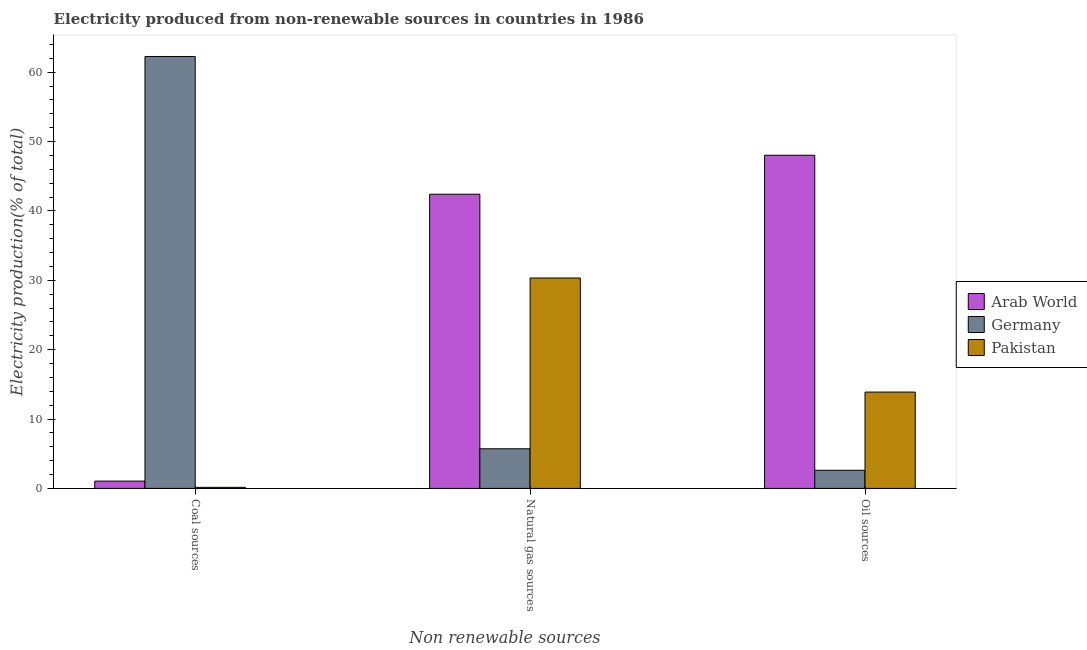How many different coloured bars are there?
Make the answer very short. 3. How many groups of bars are there?
Keep it short and to the point. 3. Are the number of bars on each tick of the X-axis equal?
Your response must be concise. Yes. What is the label of the 1st group of bars from the left?
Ensure brevity in your answer.  Coal sources. What is the percentage of electricity produced by coal in Arab World?
Keep it short and to the point. 1.06. Across all countries, what is the maximum percentage of electricity produced by coal?
Offer a terse response. 62.26. Across all countries, what is the minimum percentage of electricity produced by coal?
Offer a very short reply. 0.16. In which country was the percentage of electricity produced by natural gas maximum?
Ensure brevity in your answer.  Arab World. What is the total percentage of electricity produced by natural gas in the graph?
Give a very brief answer. 78.45. What is the difference between the percentage of electricity produced by oil sources in Germany and that in Arab World?
Offer a very short reply. -45.41. What is the difference between the percentage of electricity produced by oil sources in Pakistan and the percentage of electricity produced by natural gas in Arab World?
Your answer should be compact. -28.52. What is the average percentage of electricity produced by coal per country?
Your answer should be very brief. 21.16. What is the difference between the percentage of electricity produced by natural gas and percentage of electricity produced by oil sources in Arab World?
Your response must be concise. -5.62. In how many countries, is the percentage of electricity produced by coal greater than 46 %?
Make the answer very short. 1. What is the ratio of the percentage of electricity produced by natural gas in Pakistan to that in Arab World?
Provide a succinct answer. 0.72. What is the difference between the highest and the second highest percentage of electricity produced by natural gas?
Offer a terse response. 12.08. What is the difference between the highest and the lowest percentage of electricity produced by oil sources?
Keep it short and to the point. 45.41. What does the 1st bar from the left in Oil sources represents?
Ensure brevity in your answer.  Arab World. What does the 2nd bar from the right in Coal sources represents?
Ensure brevity in your answer.  Germany. Is it the case that in every country, the sum of the percentage of electricity produced by coal and percentage of electricity produced by natural gas is greater than the percentage of electricity produced by oil sources?
Give a very brief answer. No. How many bars are there?
Ensure brevity in your answer.  9. Are all the bars in the graph horizontal?
Offer a terse response. No. Does the graph contain any zero values?
Make the answer very short. No. Does the graph contain grids?
Your answer should be very brief. No. Where does the legend appear in the graph?
Provide a succinct answer. Center right. How are the legend labels stacked?
Keep it short and to the point. Vertical. What is the title of the graph?
Your answer should be compact. Electricity produced from non-renewable sources in countries in 1986. Does "Czech Republic" appear as one of the legend labels in the graph?
Provide a succinct answer. No. What is the label or title of the X-axis?
Keep it short and to the point. Non renewable sources. What is the label or title of the Y-axis?
Your answer should be compact. Electricity production(% of total). What is the Electricity production(% of total) of Arab World in Coal sources?
Your answer should be compact. 1.06. What is the Electricity production(% of total) in Germany in Coal sources?
Your answer should be very brief. 62.26. What is the Electricity production(% of total) of Pakistan in Coal sources?
Your response must be concise. 0.16. What is the Electricity production(% of total) of Arab World in Natural gas sources?
Offer a terse response. 42.41. What is the Electricity production(% of total) of Germany in Natural gas sources?
Your response must be concise. 5.71. What is the Electricity production(% of total) in Pakistan in Natural gas sources?
Your answer should be very brief. 30.33. What is the Electricity production(% of total) in Arab World in Oil sources?
Ensure brevity in your answer.  48.03. What is the Electricity production(% of total) of Germany in Oil sources?
Provide a succinct answer. 2.61. What is the Electricity production(% of total) in Pakistan in Oil sources?
Give a very brief answer. 13.89. Across all Non renewable sources, what is the maximum Electricity production(% of total) of Arab World?
Keep it short and to the point. 48.03. Across all Non renewable sources, what is the maximum Electricity production(% of total) in Germany?
Give a very brief answer. 62.26. Across all Non renewable sources, what is the maximum Electricity production(% of total) in Pakistan?
Provide a short and direct response. 30.33. Across all Non renewable sources, what is the minimum Electricity production(% of total) in Arab World?
Ensure brevity in your answer.  1.06. Across all Non renewable sources, what is the minimum Electricity production(% of total) in Germany?
Provide a succinct answer. 2.61. Across all Non renewable sources, what is the minimum Electricity production(% of total) of Pakistan?
Make the answer very short. 0.16. What is the total Electricity production(% of total) in Arab World in the graph?
Offer a terse response. 91.49. What is the total Electricity production(% of total) in Germany in the graph?
Give a very brief answer. 70.59. What is the total Electricity production(% of total) in Pakistan in the graph?
Your response must be concise. 44.37. What is the difference between the Electricity production(% of total) of Arab World in Coal sources and that in Natural gas sources?
Provide a short and direct response. -41.35. What is the difference between the Electricity production(% of total) of Germany in Coal sources and that in Natural gas sources?
Keep it short and to the point. 56.55. What is the difference between the Electricity production(% of total) in Pakistan in Coal sources and that in Natural gas sources?
Your answer should be very brief. -30.17. What is the difference between the Electricity production(% of total) in Arab World in Coal sources and that in Oil sources?
Provide a succinct answer. -46.97. What is the difference between the Electricity production(% of total) in Germany in Coal sources and that in Oil sources?
Ensure brevity in your answer.  59.65. What is the difference between the Electricity production(% of total) of Pakistan in Coal sources and that in Oil sources?
Offer a terse response. -13.73. What is the difference between the Electricity production(% of total) of Arab World in Natural gas sources and that in Oil sources?
Ensure brevity in your answer.  -5.62. What is the difference between the Electricity production(% of total) of Germany in Natural gas sources and that in Oil sources?
Your response must be concise. 3.1. What is the difference between the Electricity production(% of total) in Pakistan in Natural gas sources and that in Oil sources?
Keep it short and to the point. 16.44. What is the difference between the Electricity production(% of total) of Arab World in Coal sources and the Electricity production(% of total) of Germany in Natural gas sources?
Ensure brevity in your answer.  -4.66. What is the difference between the Electricity production(% of total) of Arab World in Coal sources and the Electricity production(% of total) of Pakistan in Natural gas sources?
Your answer should be very brief. -29.27. What is the difference between the Electricity production(% of total) of Germany in Coal sources and the Electricity production(% of total) of Pakistan in Natural gas sources?
Make the answer very short. 31.93. What is the difference between the Electricity production(% of total) of Arab World in Coal sources and the Electricity production(% of total) of Germany in Oil sources?
Make the answer very short. -1.56. What is the difference between the Electricity production(% of total) in Arab World in Coal sources and the Electricity production(% of total) in Pakistan in Oil sources?
Offer a terse response. -12.83. What is the difference between the Electricity production(% of total) in Germany in Coal sources and the Electricity production(% of total) in Pakistan in Oil sources?
Your answer should be very brief. 48.37. What is the difference between the Electricity production(% of total) in Arab World in Natural gas sources and the Electricity production(% of total) in Germany in Oil sources?
Your answer should be compact. 39.79. What is the difference between the Electricity production(% of total) of Arab World in Natural gas sources and the Electricity production(% of total) of Pakistan in Oil sources?
Keep it short and to the point. 28.52. What is the difference between the Electricity production(% of total) in Germany in Natural gas sources and the Electricity production(% of total) in Pakistan in Oil sources?
Provide a short and direct response. -8.18. What is the average Electricity production(% of total) of Arab World per Non renewable sources?
Make the answer very short. 30.5. What is the average Electricity production(% of total) in Germany per Non renewable sources?
Ensure brevity in your answer.  23.53. What is the average Electricity production(% of total) in Pakistan per Non renewable sources?
Ensure brevity in your answer.  14.79. What is the difference between the Electricity production(% of total) of Arab World and Electricity production(% of total) of Germany in Coal sources?
Give a very brief answer. -61.21. What is the difference between the Electricity production(% of total) in Arab World and Electricity production(% of total) in Pakistan in Coal sources?
Your answer should be compact. 0.9. What is the difference between the Electricity production(% of total) of Germany and Electricity production(% of total) of Pakistan in Coal sources?
Keep it short and to the point. 62.11. What is the difference between the Electricity production(% of total) in Arab World and Electricity production(% of total) in Germany in Natural gas sources?
Keep it short and to the point. 36.7. What is the difference between the Electricity production(% of total) of Arab World and Electricity production(% of total) of Pakistan in Natural gas sources?
Give a very brief answer. 12.08. What is the difference between the Electricity production(% of total) in Germany and Electricity production(% of total) in Pakistan in Natural gas sources?
Provide a succinct answer. -24.62. What is the difference between the Electricity production(% of total) in Arab World and Electricity production(% of total) in Germany in Oil sources?
Your answer should be very brief. 45.41. What is the difference between the Electricity production(% of total) in Arab World and Electricity production(% of total) in Pakistan in Oil sources?
Your answer should be compact. 34.14. What is the difference between the Electricity production(% of total) in Germany and Electricity production(% of total) in Pakistan in Oil sources?
Your answer should be very brief. -11.27. What is the ratio of the Electricity production(% of total) of Arab World in Coal sources to that in Natural gas sources?
Your answer should be compact. 0.02. What is the ratio of the Electricity production(% of total) of Germany in Coal sources to that in Natural gas sources?
Offer a very short reply. 10.9. What is the ratio of the Electricity production(% of total) of Pakistan in Coal sources to that in Natural gas sources?
Ensure brevity in your answer.  0.01. What is the ratio of the Electricity production(% of total) of Arab World in Coal sources to that in Oil sources?
Keep it short and to the point. 0.02. What is the ratio of the Electricity production(% of total) of Germany in Coal sources to that in Oil sources?
Give a very brief answer. 23.81. What is the ratio of the Electricity production(% of total) of Pakistan in Coal sources to that in Oil sources?
Offer a terse response. 0.01. What is the ratio of the Electricity production(% of total) of Arab World in Natural gas sources to that in Oil sources?
Your answer should be very brief. 0.88. What is the ratio of the Electricity production(% of total) in Germany in Natural gas sources to that in Oil sources?
Provide a short and direct response. 2.19. What is the ratio of the Electricity production(% of total) of Pakistan in Natural gas sources to that in Oil sources?
Offer a terse response. 2.18. What is the difference between the highest and the second highest Electricity production(% of total) of Arab World?
Keep it short and to the point. 5.62. What is the difference between the highest and the second highest Electricity production(% of total) of Germany?
Provide a succinct answer. 56.55. What is the difference between the highest and the second highest Electricity production(% of total) of Pakistan?
Provide a succinct answer. 16.44. What is the difference between the highest and the lowest Electricity production(% of total) of Arab World?
Make the answer very short. 46.97. What is the difference between the highest and the lowest Electricity production(% of total) in Germany?
Keep it short and to the point. 59.65. What is the difference between the highest and the lowest Electricity production(% of total) in Pakistan?
Offer a very short reply. 30.17. 